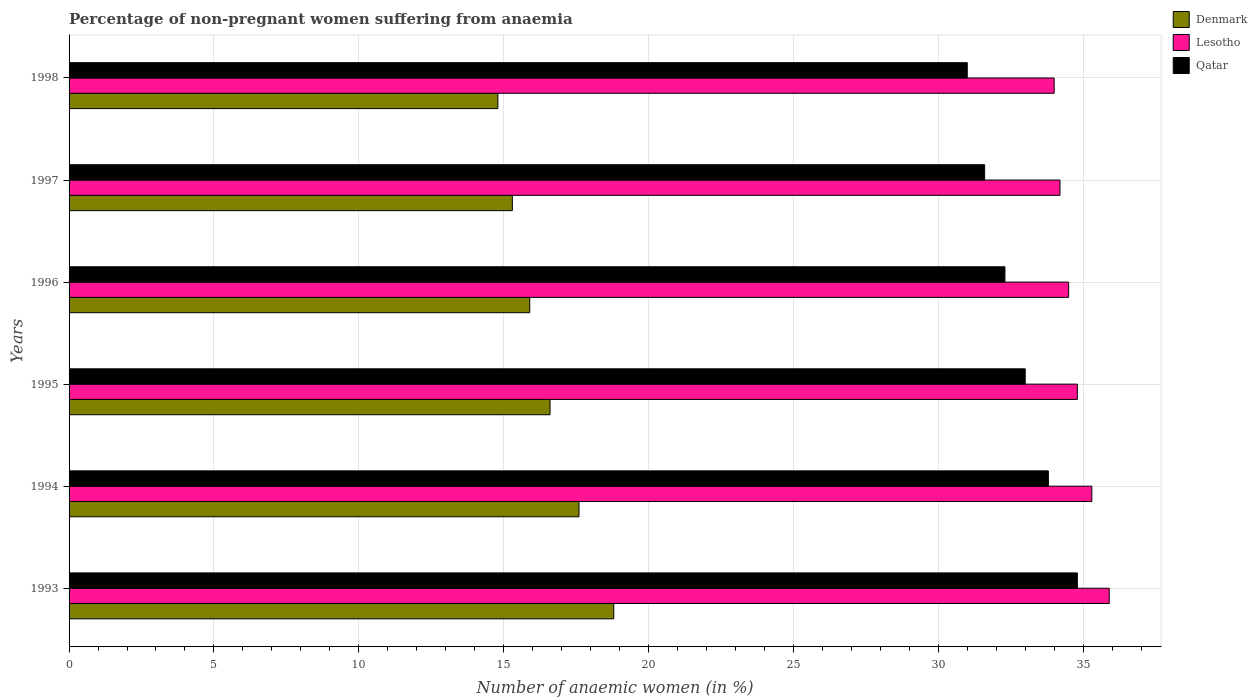Are the number of bars per tick equal to the number of legend labels?
Your answer should be very brief. Yes. Are the number of bars on each tick of the Y-axis equal?
Offer a terse response. Yes. How many bars are there on the 5th tick from the top?
Keep it short and to the point. 3. In how many cases, is the number of bars for a given year not equal to the number of legend labels?
Offer a terse response. 0. Across all years, what is the maximum percentage of non-pregnant women suffering from anaemia in Denmark?
Your response must be concise. 18.8. In which year was the percentage of non-pregnant women suffering from anaemia in Denmark minimum?
Keep it short and to the point. 1998. What is the total percentage of non-pregnant women suffering from anaemia in Lesotho in the graph?
Your answer should be compact. 208.7. What is the difference between the percentage of non-pregnant women suffering from anaemia in Lesotho in 1993 and that in 1994?
Provide a succinct answer. 0.6. What is the average percentage of non-pregnant women suffering from anaemia in Qatar per year?
Your answer should be compact. 32.75. In the year 1997, what is the difference between the percentage of non-pregnant women suffering from anaemia in Qatar and percentage of non-pregnant women suffering from anaemia in Lesotho?
Your answer should be very brief. -2.6. In how many years, is the percentage of non-pregnant women suffering from anaemia in Denmark greater than 32 %?
Your answer should be very brief. 0. What is the ratio of the percentage of non-pregnant women suffering from anaemia in Denmark in 1994 to that in 1997?
Provide a short and direct response. 1.15. Is the percentage of non-pregnant women suffering from anaemia in Lesotho in 1994 less than that in 1995?
Make the answer very short. No. Is the difference between the percentage of non-pregnant women suffering from anaemia in Qatar in 1995 and 1996 greater than the difference between the percentage of non-pregnant women suffering from anaemia in Lesotho in 1995 and 1996?
Offer a terse response. Yes. What is the difference between the highest and the second highest percentage of non-pregnant women suffering from anaemia in Lesotho?
Offer a very short reply. 0.6. What is the difference between the highest and the lowest percentage of non-pregnant women suffering from anaemia in Qatar?
Your response must be concise. 3.8. Is the sum of the percentage of non-pregnant women suffering from anaemia in Denmark in 1997 and 1998 greater than the maximum percentage of non-pregnant women suffering from anaemia in Lesotho across all years?
Make the answer very short. No. What does the 1st bar from the top in 1994 represents?
Provide a succinct answer. Qatar. What does the 3rd bar from the bottom in 1993 represents?
Your response must be concise. Qatar. Are all the bars in the graph horizontal?
Your response must be concise. Yes. Are the values on the major ticks of X-axis written in scientific E-notation?
Keep it short and to the point. No. Does the graph contain any zero values?
Provide a short and direct response. No. Where does the legend appear in the graph?
Ensure brevity in your answer.  Top right. How many legend labels are there?
Give a very brief answer. 3. How are the legend labels stacked?
Offer a terse response. Vertical. What is the title of the graph?
Give a very brief answer. Percentage of non-pregnant women suffering from anaemia. Does "Slovenia" appear as one of the legend labels in the graph?
Give a very brief answer. No. What is the label or title of the X-axis?
Ensure brevity in your answer.  Number of anaemic women (in %). What is the label or title of the Y-axis?
Ensure brevity in your answer.  Years. What is the Number of anaemic women (in %) in Lesotho in 1993?
Give a very brief answer. 35.9. What is the Number of anaemic women (in %) in Qatar in 1993?
Provide a short and direct response. 34.8. What is the Number of anaemic women (in %) in Denmark in 1994?
Your response must be concise. 17.6. What is the Number of anaemic women (in %) in Lesotho in 1994?
Provide a succinct answer. 35.3. What is the Number of anaemic women (in %) in Qatar in 1994?
Make the answer very short. 33.8. What is the Number of anaemic women (in %) in Lesotho in 1995?
Offer a very short reply. 34.8. What is the Number of anaemic women (in %) in Qatar in 1995?
Make the answer very short. 33. What is the Number of anaemic women (in %) of Lesotho in 1996?
Your response must be concise. 34.5. What is the Number of anaemic women (in %) of Qatar in 1996?
Your answer should be compact. 32.3. What is the Number of anaemic women (in %) of Denmark in 1997?
Your answer should be very brief. 15.3. What is the Number of anaemic women (in %) of Lesotho in 1997?
Offer a very short reply. 34.2. What is the Number of anaemic women (in %) of Qatar in 1997?
Make the answer very short. 31.6. What is the Number of anaemic women (in %) of Qatar in 1998?
Your answer should be very brief. 31. Across all years, what is the maximum Number of anaemic women (in %) in Denmark?
Ensure brevity in your answer.  18.8. Across all years, what is the maximum Number of anaemic women (in %) of Lesotho?
Keep it short and to the point. 35.9. Across all years, what is the maximum Number of anaemic women (in %) in Qatar?
Keep it short and to the point. 34.8. Across all years, what is the minimum Number of anaemic women (in %) of Denmark?
Provide a succinct answer. 14.8. What is the total Number of anaemic women (in %) of Lesotho in the graph?
Make the answer very short. 208.7. What is the total Number of anaemic women (in %) of Qatar in the graph?
Make the answer very short. 196.5. What is the difference between the Number of anaemic women (in %) in Denmark in 1993 and that in 1994?
Your response must be concise. 1.2. What is the difference between the Number of anaemic women (in %) in Lesotho in 1993 and that in 1994?
Your response must be concise. 0.6. What is the difference between the Number of anaemic women (in %) in Denmark in 1993 and that in 1995?
Your answer should be very brief. 2.2. What is the difference between the Number of anaemic women (in %) in Lesotho in 1993 and that in 1995?
Your answer should be very brief. 1.1. What is the difference between the Number of anaemic women (in %) in Lesotho in 1993 and that in 1996?
Make the answer very short. 1.4. What is the difference between the Number of anaemic women (in %) of Denmark in 1993 and that in 1997?
Your answer should be compact. 3.5. What is the difference between the Number of anaemic women (in %) in Qatar in 1993 and that in 1997?
Your answer should be very brief. 3.2. What is the difference between the Number of anaemic women (in %) in Lesotho in 1993 and that in 1998?
Give a very brief answer. 1.9. What is the difference between the Number of anaemic women (in %) in Qatar in 1993 and that in 1998?
Provide a succinct answer. 3.8. What is the difference between the Number of anaemic women (in %) of Denmark in 1994 and that in 1995?
Offer a terse response. 1. What is the difference between the Number of anaemic women (in %) of Qatar in 1994 and that in 1995?
Your answer should be compact. 0.8. What is the difference between the Number of anaemic women (in %) of Denmark in 1994 and that in 1996?
Make the answer very short. 1.7. What is the difference between the Number of anaemic women (in %) in Lesotho in 1994 and that in 1996?
Make the answer very short. 0.8. What is the difference between the Number of anaemic women (in %) of Qatar in 1994 and that in 1996?
Offer a very short reply. 1.5. What is the difference between the Number of anaemic women (in %) in Denmark in 1994 and that in 1997?
Ensure brevity in your answer.  2.3. What is the difference between the Number of anaemic women (in %) in Denmark in 1994 and that in 1998?
Your answer should be very brief. 2.8. What is the difference between the Number of anaemic women (in %) in Lesotho in 1994 and that in 1998?
Offer a terse response. 1.3. What is the difference between the Number of anaemic women (in %) in Qatar in 1994 and that in 1998?
Give a very brief answer. 2.8. What is the difference between the Number of anaemic women (in %) of Denmark in 1995 and that in 1996?
Ensure brevity in your answer.  0.7. What is the difference between the Number of anaemic women (in %) in Qatar in 1995 and that in 1996?
Your answer should be compact. 0.7. What is the difference between the Number of anaemic women (in %) in Lesotho in 1995 and that in 1998?
Provide a succinct answer. 0.8. What is the difference between the Number of anaemic women (in %) in Denmark in 1996 and that in 1998?
Keep it short and to the point. 1.1. What is the difference between the Number of anaemic women (in %) of Lesotho in 1996 and that in 1998?
Give a very brief answer. 0.5. What is the difference between the Number of anaemic women (in %) in Lesotho in 1997 and that in 1998?
Offer a terse response. 0.2. What is the difference between the Number of anaemic women (in %) of Qatar in 1997 and that in 1998?
Provide a succinct answer. 0.6. What is the difference between the Number of anaemic women (in %) of Denmark in 1993 and the Number of anaemic women (in %) of Lesotho in 1994?
Offer a very short reply. -16.5. What is the difference between the Number of anaemic women (in %) in Denmark in 1993 and the Number of anaemic women (in %) in Qatar in 1994?
Provide a succinct answer. -15. What is the difference between the Number of anaemic women (in %) of Lesotho in 1993 and the Number of anaemic women (in %) of Qatar in 1994?
Provide a short and direct response. 2.1. What is the difference between the Number of anaemic women (in %) in Denmark in 1993 and the Number of anaemic women (in %) in Qatar in 1995?
Offer a very short reply. -14.2. What is the difference between the Number of anaemic women (in %) in Denmark in 1993 and the Number of anaemic women (in %) in Lesotho in 1996?
Your answer should be very brief. -15.7. What is the difference between the Number of anaemic women (in %) in Denmark in 1993 and the Number of anaemic women (in %) in Lesotho in 1997?
Offer a very short reply. -15.4. What is the difference between the Number of anaemic women (in %) of Denmark in 1993 and the Number of anaemic women (in %) of Qatar in 1997?
Your response must be concise. -12.8. What is the difference between the Number of anaemic women (in %) in Lesotho in 1993 and the Number of anaemic women (in %) in Qatar in 1997?
Provide a short and direct response. 4.3. What is the difference between the Number of anaemic women (in %) in Denmark in 1993 and the Number of anaemic women (in %) in Lesotho in 1998?
Give a very brief answer. -15.2. What is the difference between the Number of anaemic women (in %) in Denmark in 1993 and the Number of anaemic women (in %) in Qatar in 1998?
Give a very brief answer. -12.2. What is the difference between the Number of anaemic women (in %) of Lesotho in 1993 and the Number of anaemic women (in %) of Qatar in 1998?
Your answer should be compact. 4.9. What is the difference between the Number of anaemic women (in %) of Denmark in 1994 and the Number of anaemic women (in %) of Lesotho in 1995?
Your response must be concise. -17.2. What is the difference between the Number of anaemic women (in %) in Denmark in 1994 and the Number of anaemic women (in %) in Qatar in 1995?
Provide a succinct answer. -15.4. What is the difference between the Number of anaemic women (in %) of Lesotho in 1994 and the Number of anaemic women (in %) of Qatar in 1995?
Make the answer very short. 2.3. What is the difference between the Number of anaemic women (in %) of Denmark in 1994 and the Number of anaemic women (in %) of Lesotho in 1996?
Give a very brief answer. -16.9. What is the difference between the Number of anaemic women (in %) in Denmark in 1994 and the Number of anaemic women (in %) in Qatar in 1996?
Make the answer very short. -14.7. What is the difference between the Number of anaemic women (in %) of Lesotho in 1994 and the Number of anaemic women (in %) of Qatar in 1996?
Make the answer very short. 3. What is the difference between the Number of anaemic women (in %) of Denmark in 1994 and the Number of anaemic women (in %) of Lesotho in 1997?
Ensure brevity in your answer.  -16.6. What is the difference between the Number of anaemic women (in %) of Denmark in 1994 and the Number of anaemic women (in %) of Lesotho in 1998?
Your response must be concise. -16.4. What is the difference between the Number of anaemic women (in %) in Lesotho in 1994 and the Number of anaemic women (in %) in Qatar in 1998?
Keep it short and to the point. 4.3. What is the difference between the Number of anaemic women (in %) in Denmark in 1995 and the Number of anaemic women (in %) in Lesotho in 1996?
Your answer should be compact. -17.9. What is the difference between the Number of anaemic women (in %) of Denmark in 1995 and the Number of anaemic women (in %) of Qatar in 1996?
Keep it short and to the point. -15.7. What is the difference between the Number of anaemic women (in %) of Lesotho in 1995 and the Number of anaemic women (in %) of Qatar in 1996?
Your response must be concise. 2.5. What is the difference between the Number of anaemic women (in %) in Denmark in 1995 and the Number of anaemic women (in %) in Lesotho in 1997?
Ensure brevity in your answer.  -17.6. What is the difference between the Number of anaemic women (in %) in Denmark in 1995 and the Number of anaemic women (in %) in Qatar in 1997?
Your response must be concise. -15. What is the difference between the Number of anaemic women (in %) in Denmark in 1995 and the Number of anaemic women (in %) in Lesotho in 1998?
Provide a succinct answer. -17.4. What is the difference between the Number of anaemic women (in %) in Denmark in 1995 and the Number of anaemic women (in %) in Qatar in 1998?
Keep it short and to the point. -14.4. What is the difference between the Number of anaemic women (in %) in Denmark in 1996 and the Number of anaemic women (in %) in Lesotho in 1997?
Provide a succinct answer. -18.3. What is the difference between the Number of anaemic women (in %) in Denmark in 1996 and the Number of anaemic women (in %) in Qatar in 1997?
Provide a succinct answer. -15.7. What is the difference between the Number of anaemic women (in %) in Lesotho in 1996 and the Number of anaemic women (in %) in Qatar in 1997?
Ensure brevity in your answer.  2.9. What is the difference between the Number of anaemic women (in %) of Denmark in 1996 and the Number of anaemic women (in %) of Lesotho in 1998?
Provide a short and direct response. -18.1. What is the difference between the Number of anaemic women (in %) in Denmark in 1996 and the Number of anaemic women (in %) in Qatar in 1998?
Your response must be concise. -15.1. What is the difference between the Number of anaemic women (in %) in Lesotho in 1996 and the Number of anaemic women (in %) in Qatar in 1998?
Ensure brevity in your answer.  3.5. What is the difference between the Number of anaemic women (in %) in Denmark in 1997 and the Number of anaemic women (in %) in Lesotho in 1998?
Offer a very short reply. -18.7. What is the difference between the Number of anaemic women (in %) of Denmark in 1997 and the Number of anaemic women (in %) of Qatar in 1998?
Provide a succinct answer. -15.7. What is the difference between the Number of anaemic women (in %) of Lesotho in 1997 and the Number of anaemic women (in %) of Qatar in 1998?
Your answer should be very brief. 3.2. What is the average Number of anaemic women (in %) in Lesotho per year?
Ensure brevity in your answer.  34.78. What is the average Number of anaemic women (in %) of Qatar per year?
Offer a terse response. 32.75. In the year 1993, what is the difference between the Number of anaemic women (in %) in Denmark and Number of anaemic women (in %) in Lesotho?
Your answer should be very brief. -17.1. In the year 1994, what is the difference between the Number of anaemic women (in %) of Denmark and Number of anaemic women (in %) of Lesotho?
Make the answer very short. -17.7. In the year 1994, what is the difference between the Number of anaemic women (in %) of Denmark and Number of anaemic women (in %) of Qatar?
Provide a short and direct response. -16.2. In the year 1994, what is the difference between the Number of anaemic women (in %) of Lesotho and Number of anaemic women (in %) of Qatar?
Make the answer very short. 1.5. In the year 1995, what is the difference between the Number of anaemic women (in %) of Denmark and Number of anaemic women (in %) of Lesotho?
Make the answer very short. -18.2. In the year 1995, what is the difference between the Number of anaemic women (in %) of Denmark and Number of anaemic women (in %) of Qatar?
Your response must be concise. -16.4. In the year 1995, what is the difference between the Number of anaemic women (in %) of Lesotho and Number of anaemic women (in %) of Qatar?
Offer a very short reply. 1.8. In the year 1996, what is the difference between the Number of anaemic women (in %) of Denmark and Number of anaemic women (in %) of Lesotho?
Offer a terse response. -18.6. In the year 1996, what is the difference between the Number of anaemic women (in %) in Denmark and Number of anaemic women (in %) in Qatar?
Give a very brief answer. -16.4. In the year 1996, what is the difference between the Number of anaemic women (in %) of Lesotho and Number of anaemic women (in %) of Qatar?
Keep it short and to the point. 2.2. In the year 1997, what is the difference between the Number of anaemic women (in %) in Denmark and Number of anaemic women (in %) in Lesotho?
Offer a very short reply. -18.9. In the year 1997, what is the difference between the Number of anaemic women (in %) in Denmark and Number of anaemic women (in %) in Qatar?
Provide a succinct answer. -16.3. In the year 1997, what is the difference between the Number of anaemic women (in %) in Lesotho and Number of anaemic women (in %) in Qatar?
Offer a terse response. 2.6. In the year 1998, what is the difference between the Number of anaemic women (in %) in Denmark and Number of anaemic women (in %) in Lesotho?
Make the answer very short. -19.2. In the year 1998, what is the difference between the Number of anaemic women (in %) of Denmark and Number of anaemic women (in %) of Qatar?
Your response must be concise. -16.2. In the year 1998, what is the difference between the Number of anaemic women (in %) of Lesotho and Number of anaemic women (in %) of Qatar?
Your response must be concise. 3. What is the ratio of the Number of anaemic women (in %) in Denmark in 1993 to that in 1994?
Make the answer very short. 1.07. What is the ratio of the Number of anaemic women (in %) of Qatar in 1993 to that in 1994?
Your answer should be compact. 1.03. What is the ratio of the Number of anaemic women (in %) of Denmark in 1993 to that in 1995?
Offer a terse response. 1.13. What is the ratio of the Number of anaemic women (in %) of Lesotho in 1993 to that in 1995?
Your answer should be very brief. 1.03. What is the ratio of the Number of anaemic women (in %) of Qatar in 1993 to that in 1995?
Ensure brevity in your answer.  1.05. What is the ratio of the Number of anaemic women (in %) of Denmark in 1993 to that in 1996?
Provide a short and direct response. 1.18. What is the ratio of the Number of anaemic women (in %) of Lesotho in 1993 to that in 1996?
Provide a short and direct response. 1.04. What is the ratio of the Number of anaemic women (in %) in Qatar in 1993 to that in 1996?
Provide a short and direct response. 1.08. What is the ratio of the Number of anaemic women (in %) of Denmark in 1993 to that in 1997?
Give a very brief answer. 1.23. What is the ratio of the Number of anaemic women (in %) in Lesotho in 1993 to that in 1997?
Keep it short and to the point. 1.05. What is the ratio of the Number of anaemic women (in %) in Qatar in 1993 to that in 1997?
Your answer should be very brief. 1.1. What is the ratio of the Number of anaemic women (in %) in Denmark in 1993 to that in 1998?
Your answer should be very brief. 1.27. What is the ratio of the Number of anaemic women (in %) in Lesotho in 1993 to that in 1998?
Provide a succinct answer. 1.06. What is the ratio of the Number of anaemic women (in %) of Qatar in 1993 to that in 1998?
Your answer should be very brief. 1.12. What is the ratio of the Number of anaemic women (in %) of Denmark in 1994 to that in 1995?
Ensure brevity in your answer.  1.06. What is the ratio of the Number of anaemic women (in %) of Lesotho in 1994 to that in 1995?
Keep it short and to the point. 1.01. What is the ratio of the Number of anaemic women (in %) in Qatar in 1994 to that in 1995?
Offer a very short reply. 1.02. What is the ratio of the Number of anaemic women (in %) in Denmark in 1994 to that in 1996?
Provide a short and direct response. 1.11. What is the ratio of the Number of anaemic women (in %) in Lesotho in 1994 to that in 1996?
Provide a succinct answer. 1.02. What is the ratio of the Number of anaemic women (in %) of Qatar in 1994 to that in 1996?
Keep it short and to the point. 1.05. What is the ratio of the Number of anaemic women (in %) in Denmark in 1994 to that in 1997?
Offer a terse response. 1.15. What is the ratio of the Number of anaemic women (in %) of Lesotho in 1994 to that in 1997?
Offer a terse response. 1.03. What is the ratio of the Number of anaemic women (in %) of Qatar in 1994 to that in 1997?
Keep it short and to the point. 1.07. What is the ratio of the Number of anaemic women (in %) of Denmark in 1994 to that in 1998?
Give a very brief answer. 1.19. What is the ratio of the Number of anaemic women (in %) in Lesotho in 1994 to that in 1998?
Offer a terse response. 1.04. What is the ratio of the Number of anaemic women (in %) of Qatar in 1994 to that in 1998?
Keep it short and to the point. 1.09. What is the ratio of the Number of anaemic women (in %) of Denmark in 1995 to that in 1996?
Provide a short and direct response. 1.04. What is the ratio of the Number of anaemic women (in %) of Lesotho in 1995 to that in 1996?
Provide a short and direct response. 1.01. What is the ratio of the Number of anaemic women (in %) in Qatar in 1995 to that in 1996?
Your response must be concise. 1.02. What is the ratio of the Number of anaemic women (in %) in Denmark in 1995 to that in 1997?
Offer a very short reply. 1.08. What is the ratio of the Number of anaemic women (in %) of Lesotho in 1995 to that in 1997?
Give a very brief answer. 1.02. What is the ratio of the Number of anaemic women (in %) in Qatar in 1995 to that in 1997?
Keep it short and to the point. 1.04. What is the ratio of the Number of anaemic women (in %) in Denmark in 1995 to that in 1998?
Ensure brevity in your answer.  1.12. What is the ratio of the Number of anaemic women (in %) in Lesotho in 1995 to that in 1998?
Provide a succinct answer. 1.02. What is the ratio of the Number of anaemic women (in %) in Qatar in 1995 to that in 1998?
Make the answer very short. 1.06. What is the ratio of the Number of anaemic women (in %) in Denmark in 1996 to that in 1997?
Your answer should be compact. 1.04. What is the ratio of the Number of anaemic women (in %) of Lesotho in 1996 to that in 1997?
Offer a terse response. 1.01. What is the ratio of the Number of anaemic women (in %) in Qatar in 1996 to that in 1997?
Your answer should be very brief. 1.02. What is the ratio of the Number of anaemic women (in %) of Denmark in 1996 to that in 1998?
Your answer should be compact. 1.07. What is the ratio of the Number of anaemic women (in %) of Lesotho in 1996 to that in 1998?
Ensure brevity in your answer.  1.01. What is the ratio of the Number of anaemic women (in %) of Qatar in 1996 to that in 1998?
Offer a very short reply. 1.04. What is the ratio of the Number of anaemic women (in %) of Denmark in 1997 to that in 1998?
Offer a very short reply. 1.03. What is the ratio of the Number of anaemic women (in %) in Lesotho in 1997 to that in 1998?
Provide a short and direct response. 1.01. What is the ratio of the Number of anaemic women (in %) of Qatar in 1997 to that in 1998?
Your answer should be compact. 1.02. What is the difference between the highest and the second highest Number of anaemic women (in %) in Denmark?
Your answer should be very brief. 1.2. What is the difference between the highest and the second highest Number of anaemic women (in %) in Lesotho?
Give a very brief answer. 0.6. What is the difference between the highest and the lowest Number of anaemic women (in %) of Lesotho?
Your answer should be compact. 1.9. What is the difference between the highest and the lowest Number of anaemic women (in %) of Qatar?
Offer a terse response. 3.8. 